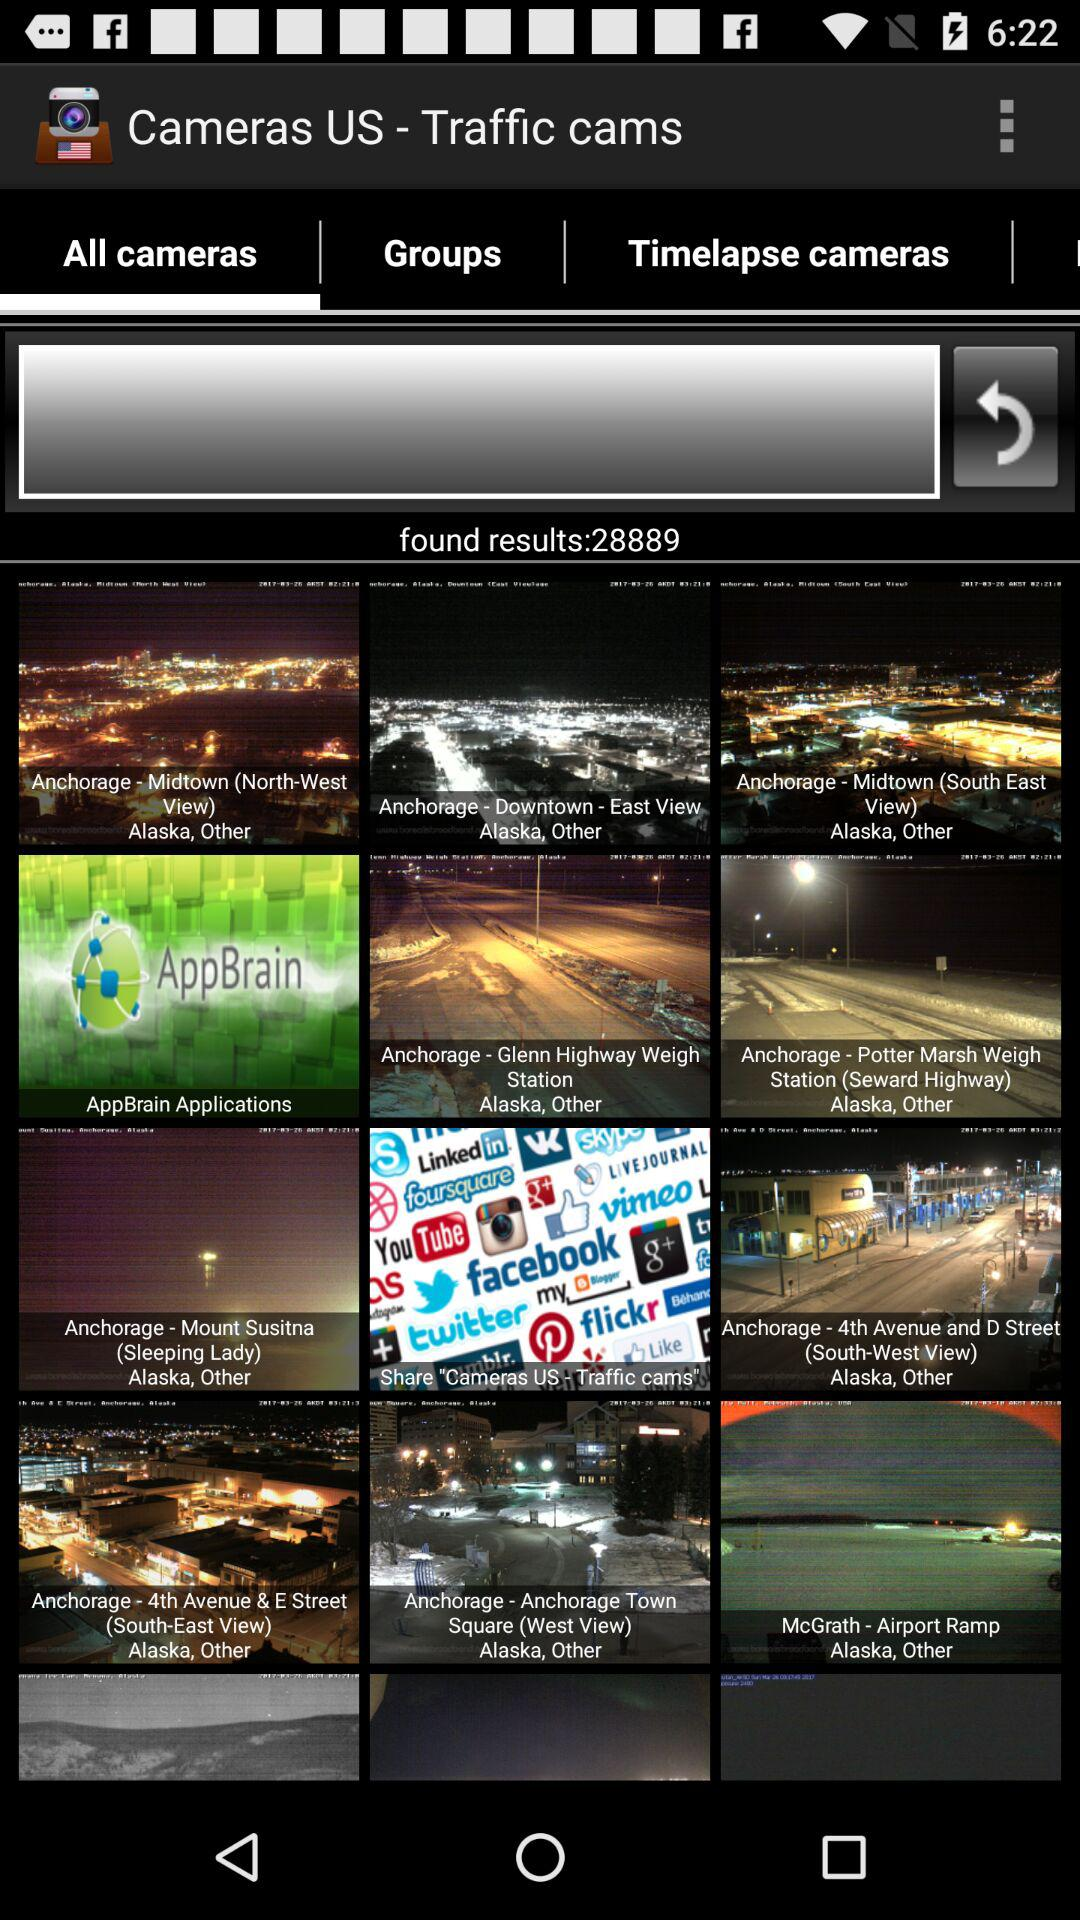How many images have been found? There have been 28889 images found. 